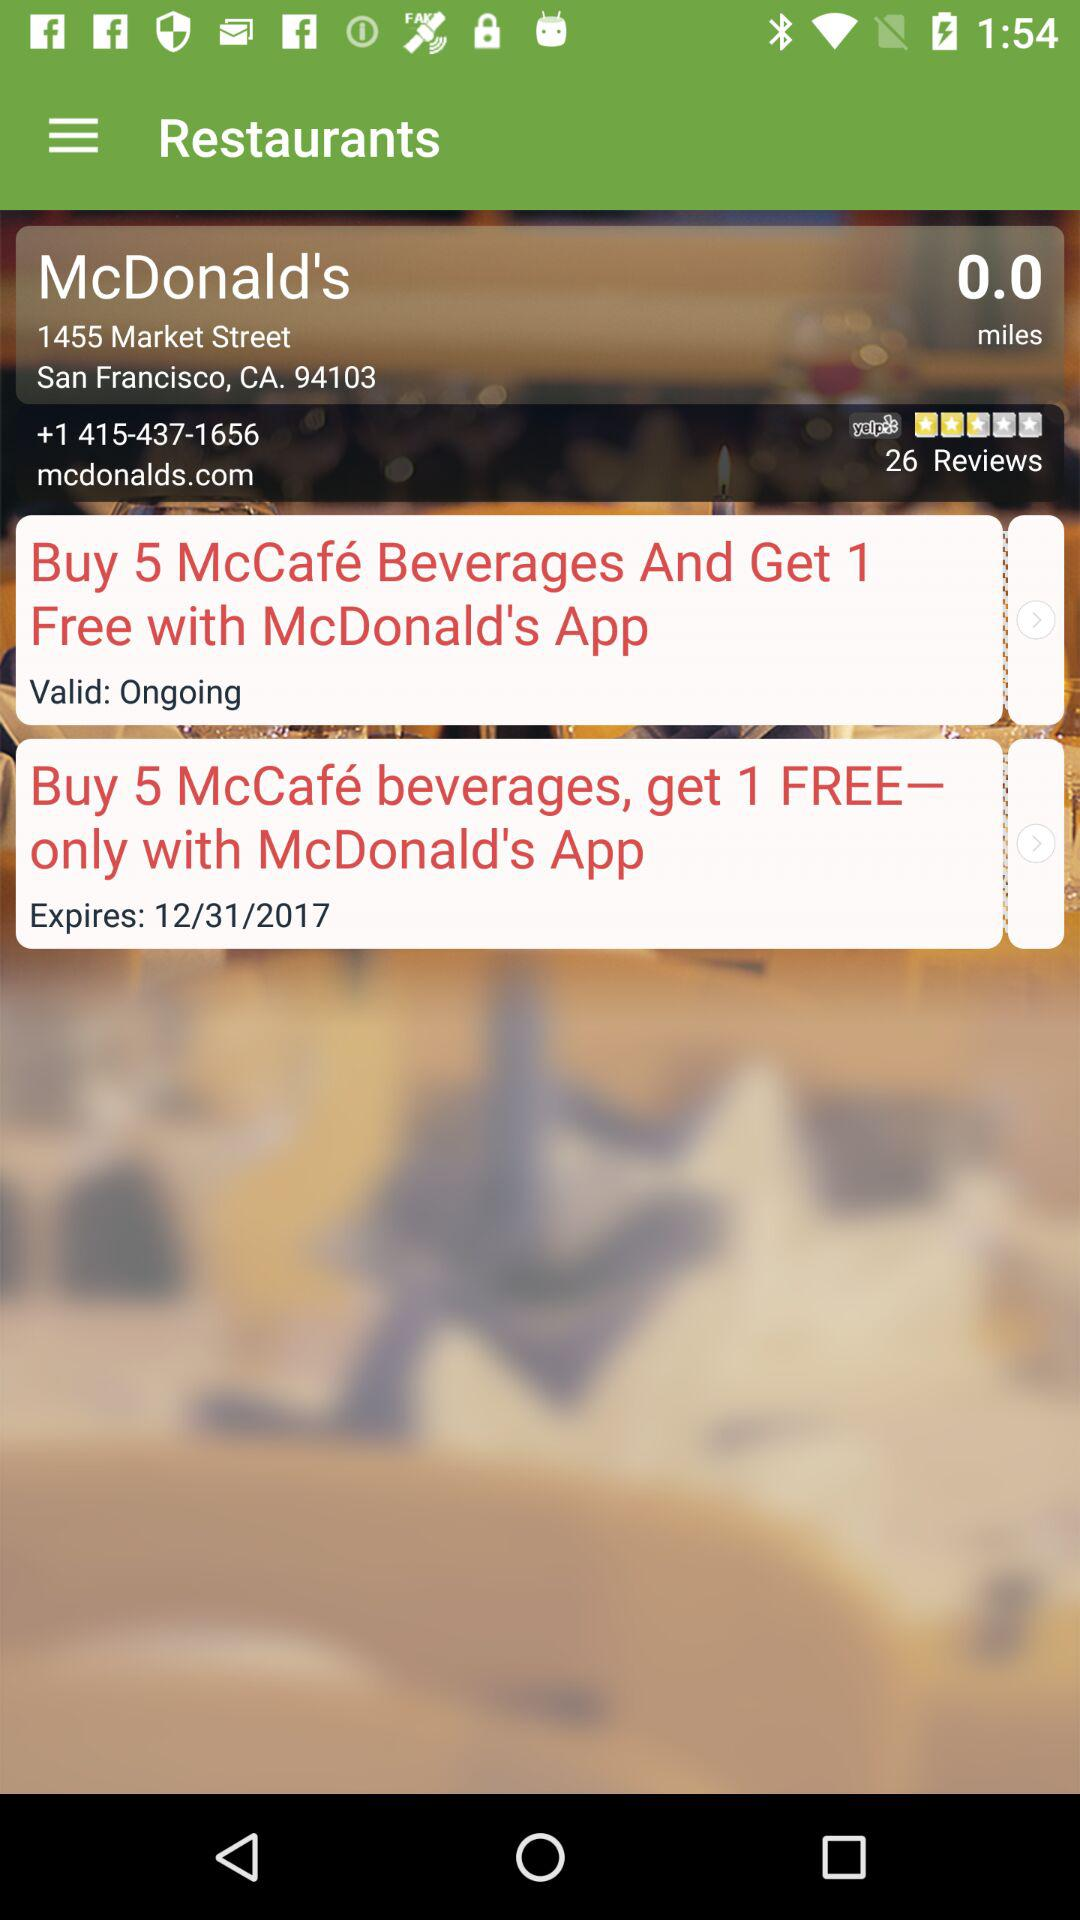What is the phone number? The phone number is +1 415-437-1656. 